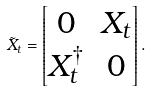<formula> <loc_0><loc_0><loc_500><loc_500>\tilde { X } _ { t } = \begin{bmatrix} 0 & X _ { t } \\ X _ { t } ^ { \dagger } & 0 \end{bmatrix} .</formula> 